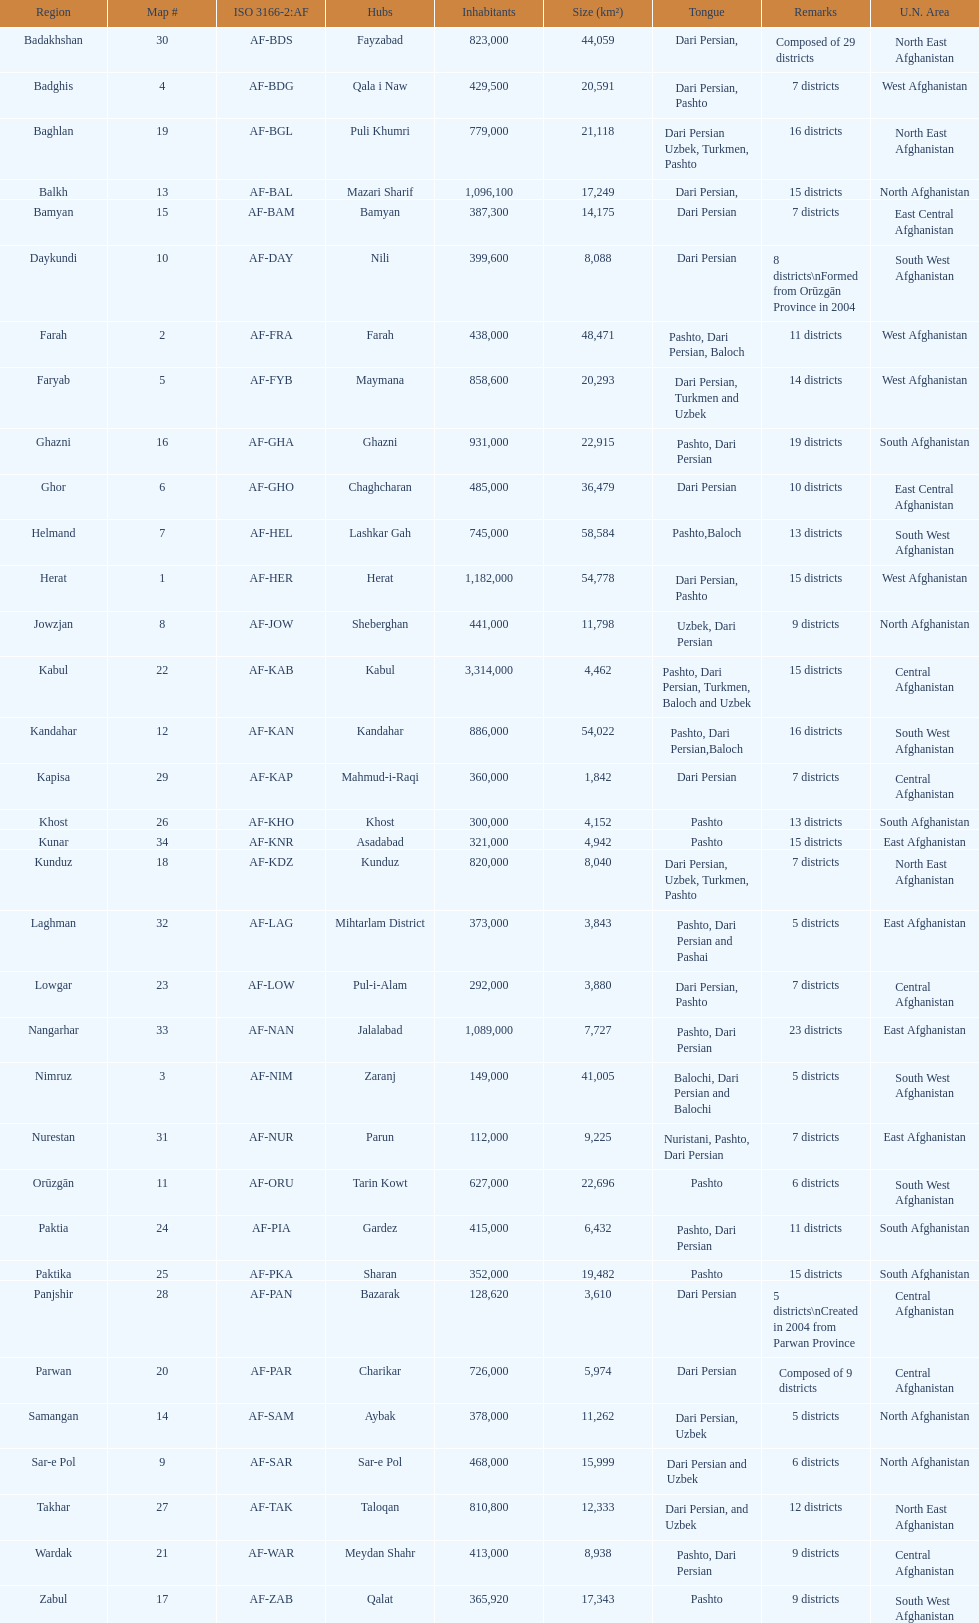Does ghor or farah have more districts? Farah. 